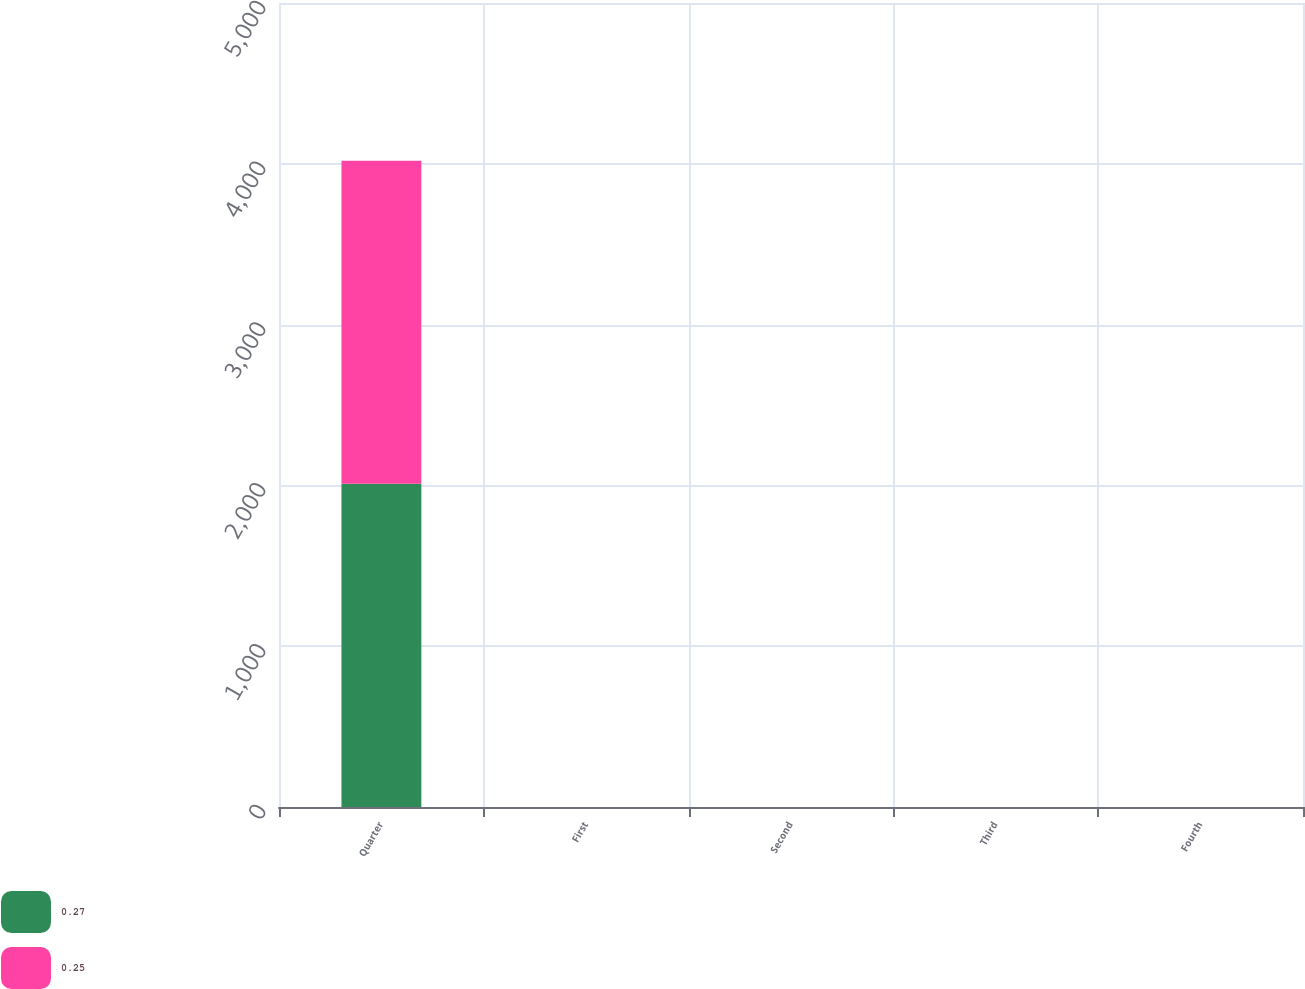Convert chart to OTSL. <chart><loc_0><loc_0><loc_500><loc_500><stacked_bar_chart><ecel><fcel>Quarter<fcel>First<fcel>Second<fcel>Third<fcel>Fourth<nl><fcel>0.27<fcel>2010<fcel>0.25<fcel>0.25<fcel>0.27<fcel>0.27<nl><fcel>0.25<fcel>2009<fcel>0.25<fcel>0.25<fcel>0.25<fcel>0.25<nl></chart> 